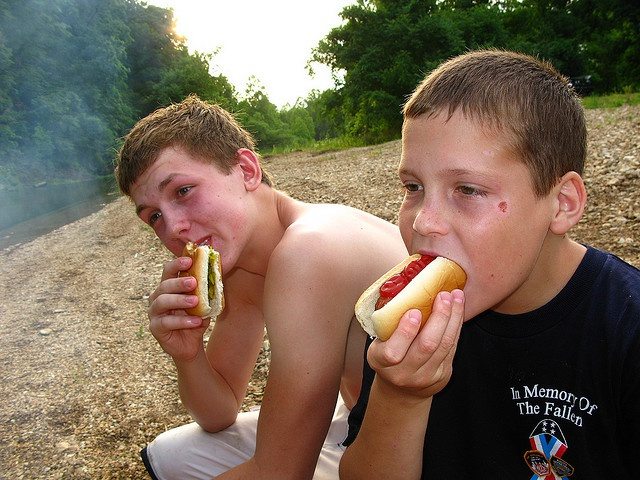Describe the objects in this image and their specific colors. I can see people in teal, black, brown, salmon, and maroon tones, people in teal, brown, maroon, and lightpink tones, hot dog in teal, khaki, beige, brown, and tan tones, and sandwich in teal, brown, tan, and beige tones in this image. 